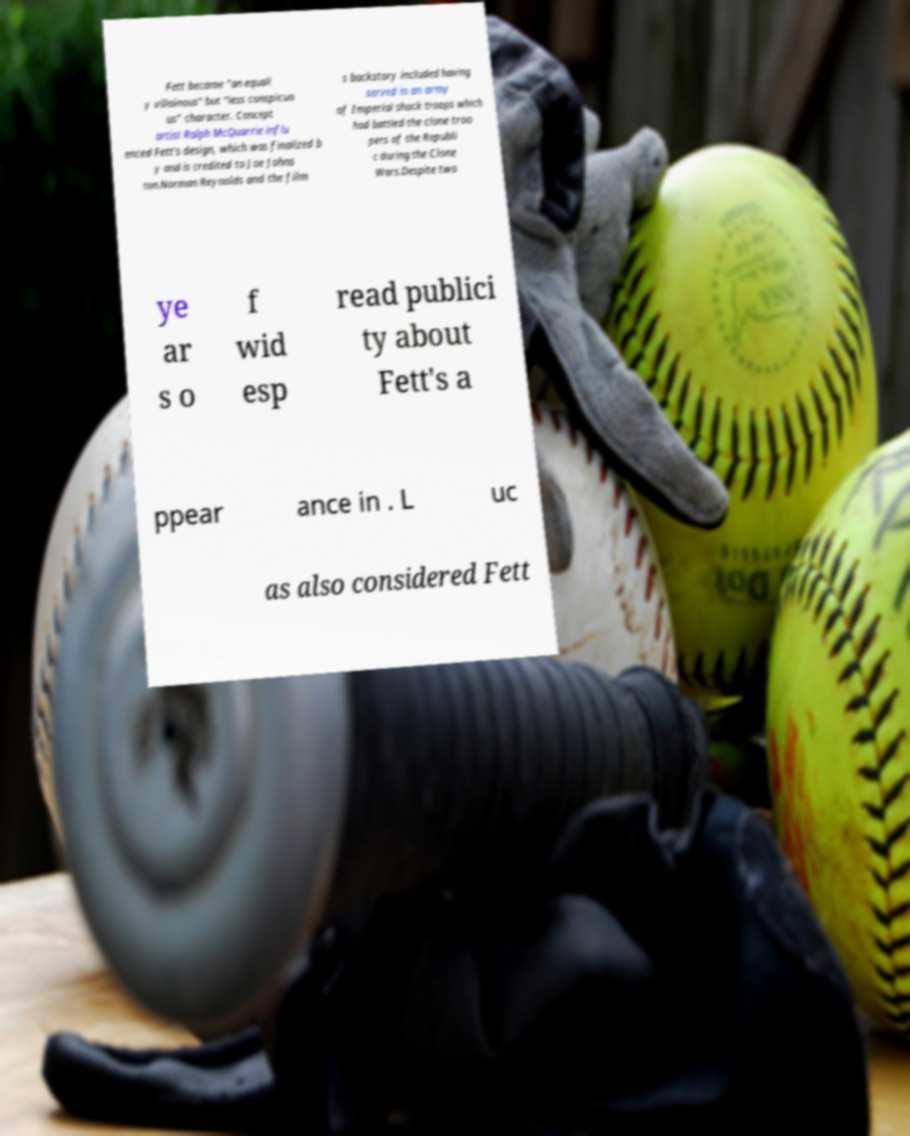Can you read and provide the text displayed in the image?This photo seems to have some interesting text. Can you extract and type it out for me? Fett became "an equall y villainous" but "less conspicuo us" character. Concept artist Ralph McQuarrie influ enced Fett's design, which was finalized b y and is credited to Joe Johns ton.Norman Reynolds and the film s backstory included having served in an army of Imperial shock troops which had battled the clone troo pers of the Republi c during the Clone Wars.Despite two ye ar s o f wid esp read publici ty about Fett's a ppear ance in . L uc as also considered Fett 